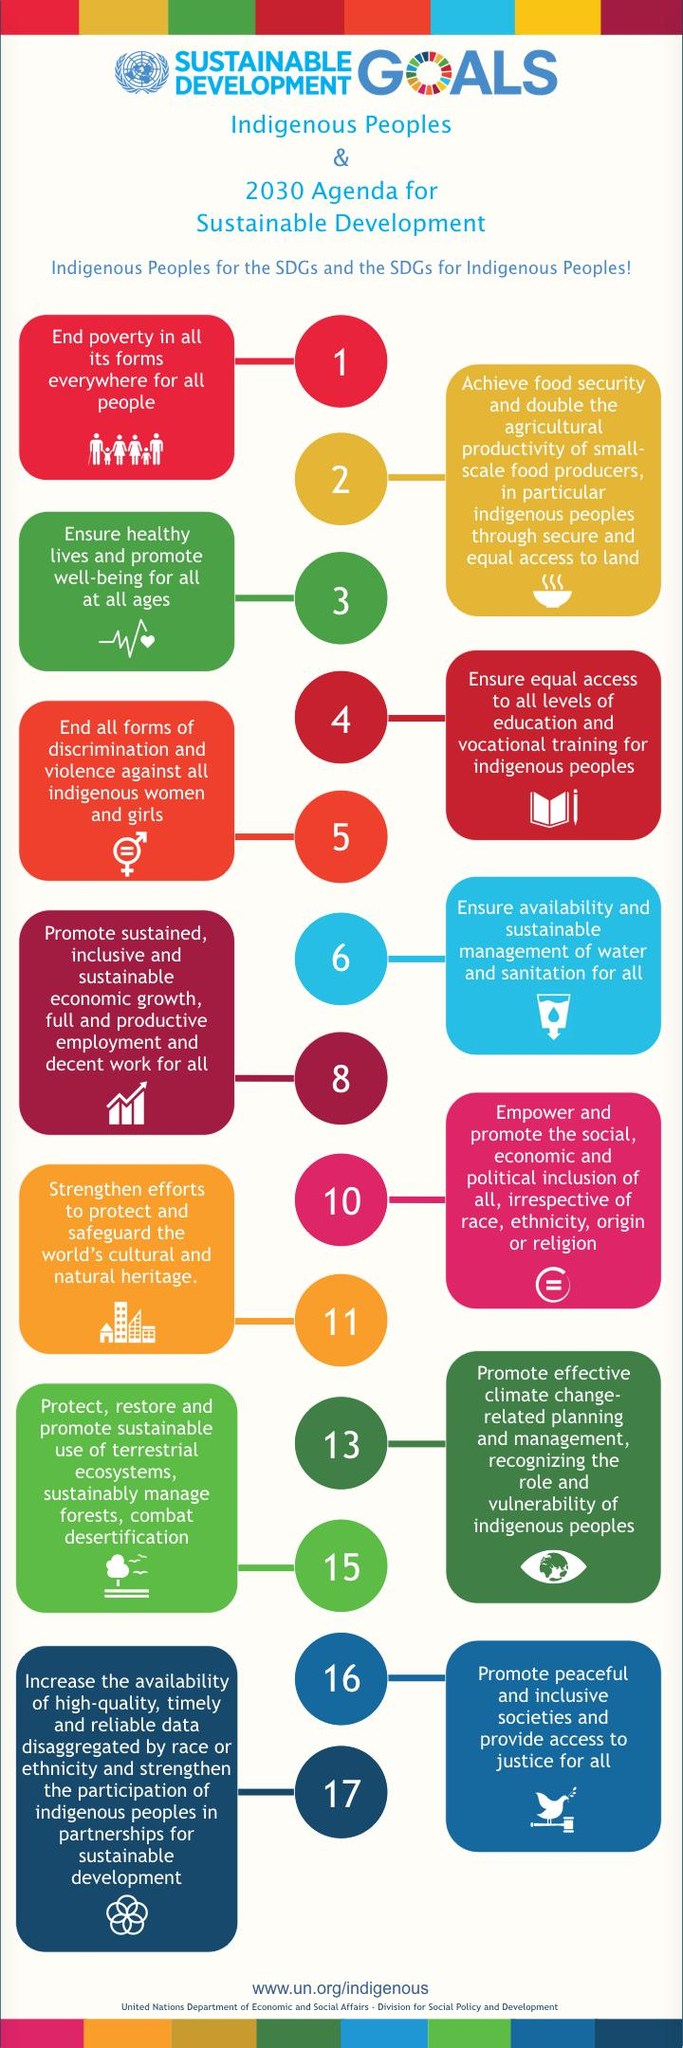Give some essential details in this illustration. The symbol indicating point number 2 is either a bowl or a book. The correct answer is a bowl. 